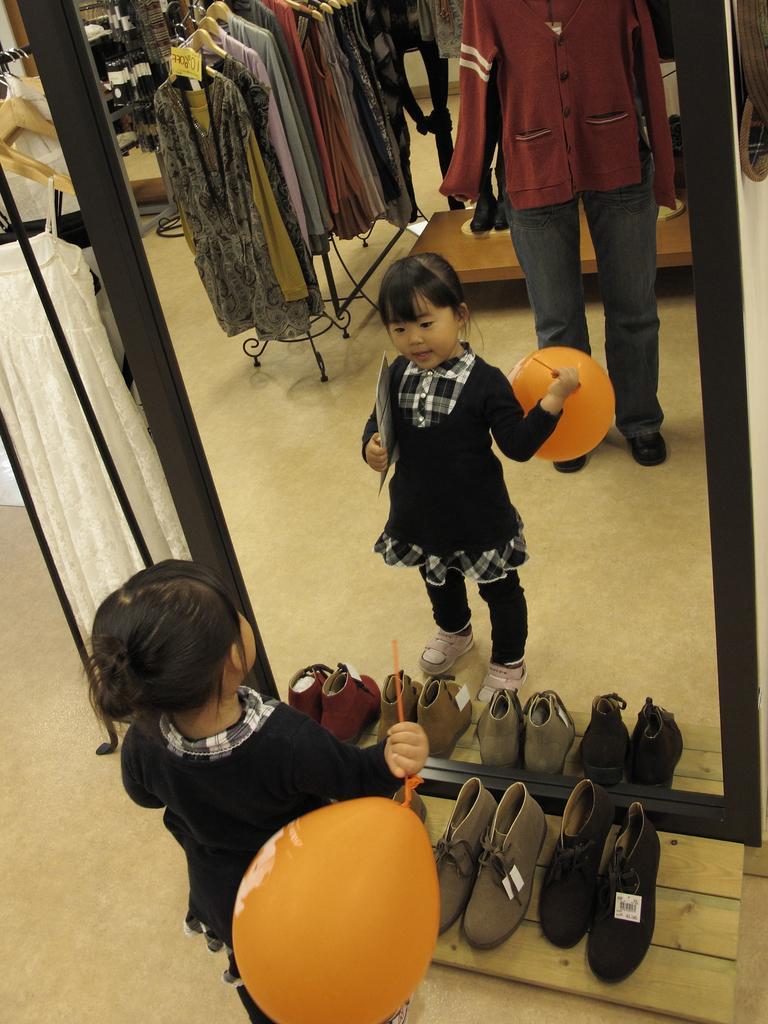How would you summarize this image in a sentence or two? At the bottom of the image a girl is standing and holding a balloon and paper. Behind her there are some footwear and mirror. In the mirror we can see some clothes. Beside the mirror we can see some clothes. 